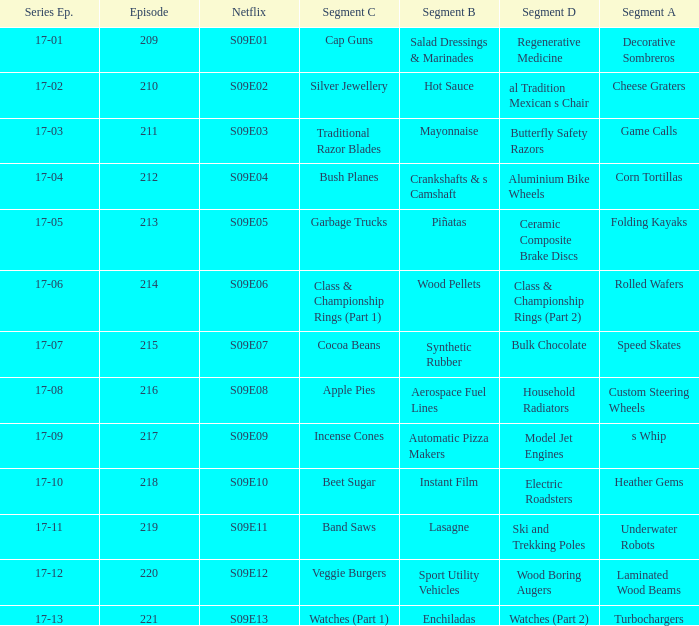Segment A of heather gems is what netflix episode? S09E10. 